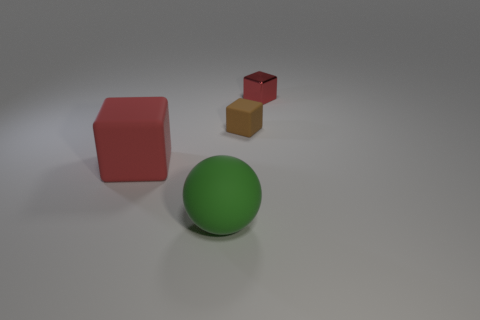Add 3 red metallic blocks. How many objects exist? 7 Subtract all cubes. How many objects are left? 1 Add 1 brown rubber things. How many brown rubber things are left? 2 Add 4 small red metal things. How many small red metal things exist? 5 Subtract 0 yellow blocks. How many objects are left? 4 Subtract all green metallic balls. Subtract all large green things. How many objects are left? 3 